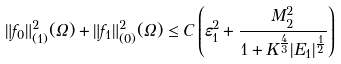Convert formula to latex. <formula><loc_0><loc_0><loc_500><loc_500>\| f _ { 0 } \| ^ { 2 } _ { ( 1 ) } ( \Omega ) + \| f _ { 1 } \| ^ { 2 } _ { ( 0 ) } ( \Omega ) \leq C \left ( \varepsilon _ { 1 } ^ { 2 } + \frac { M _ { 2 } ^ { 2 } } { 1 + K ^ { \frac { 4 } { 3 } } | E _ { 1 } | ^ { \frac { 1 } { 2 } } } \right )</formula> 